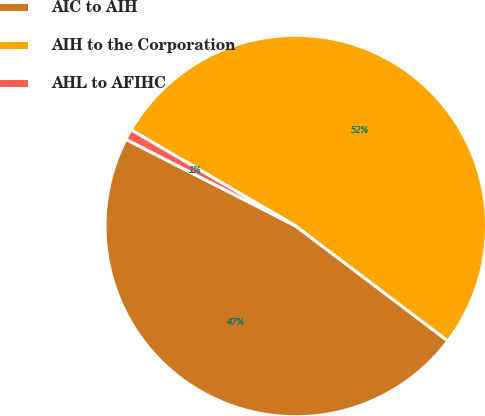Convert chart. <chart><loc_0><loc_0><loc_500><loc_500><pie_chart><fcel>AIC to AIH<fcel>AIH to the Corporation<fcel>AHL to AFIHC<nl><fcel>47.21%<fcel>51.88%<fcel>0.9%<nl></chart> 